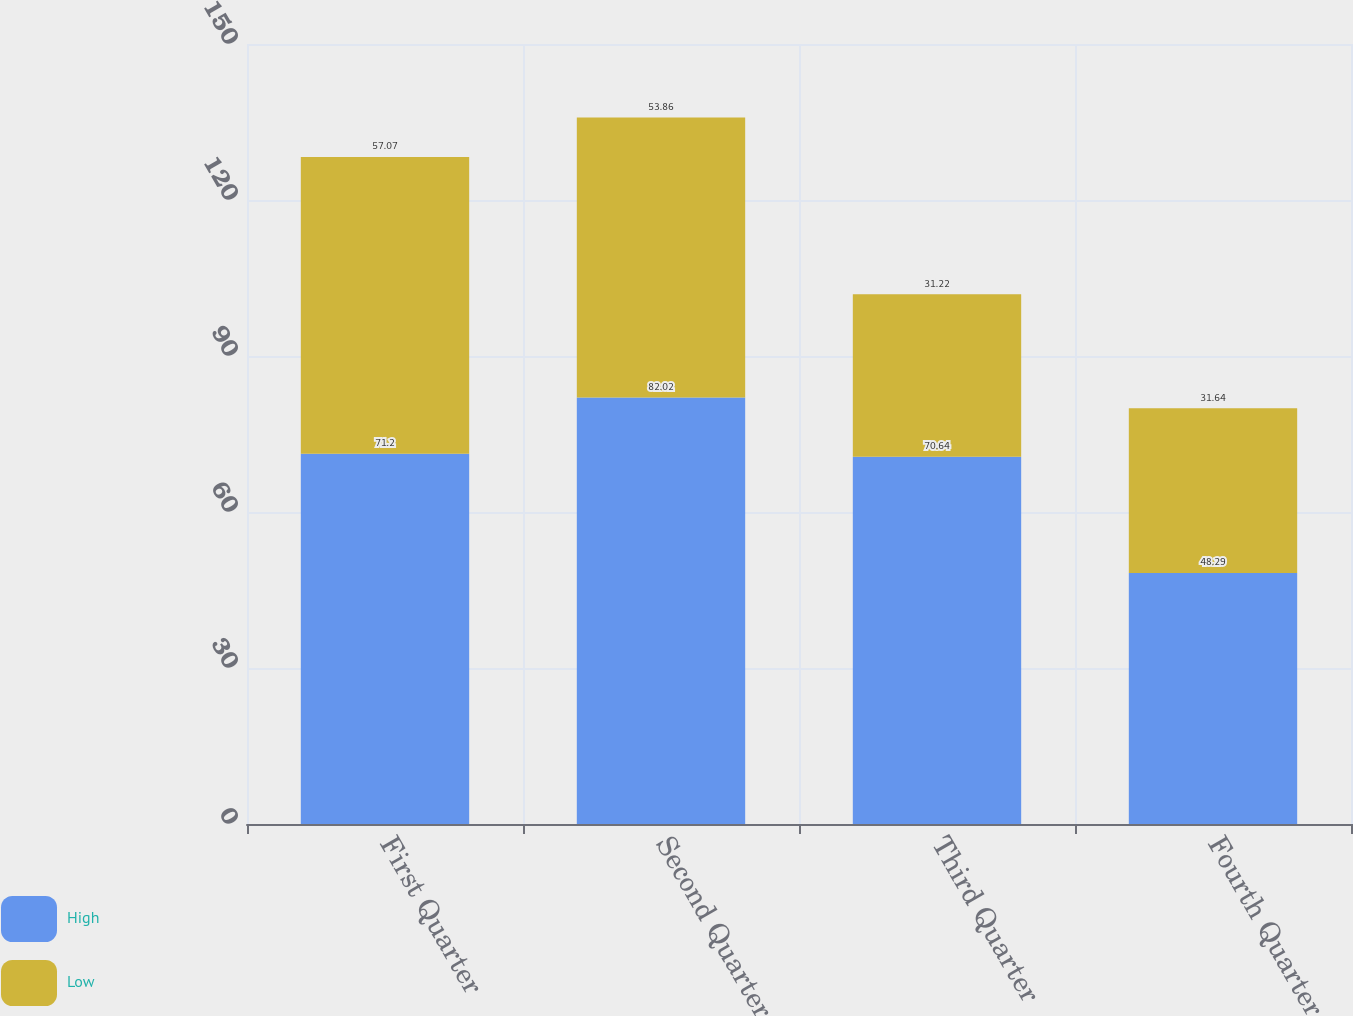Convert chart to OTSL. <chart><loc_0><loc_0><loc_500><loc_500><stacked_bar_chart><ecel><fcel>First Quarter<fcel>Second Quarter<fcel>Third Quarter<fcel>Fourth Quarter<nl><fcel>High<fcel>71.2<fcel>82.02<fcel>70.64<fcel>48.29<nl><fcel>Low<fcel>57.07<fcel>53.86<fcel>31.22<fcel>31.64<nl></chart> 